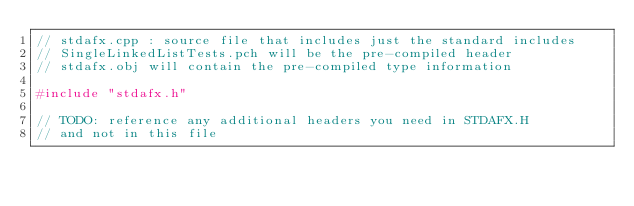<code> <loc_0><loc_0><loc_500><loc_500><_C++_>// stdafx.cpp : source file that includes just the standard includes
// SingleLinkedListTests.pch will be the pre-compiled header
// stdafx.obj will contain the pre-compiled type information

#include "stdafx.h"

// TODO: reference any additional headers you need in STDAFX.H
// and not in this file</code> 